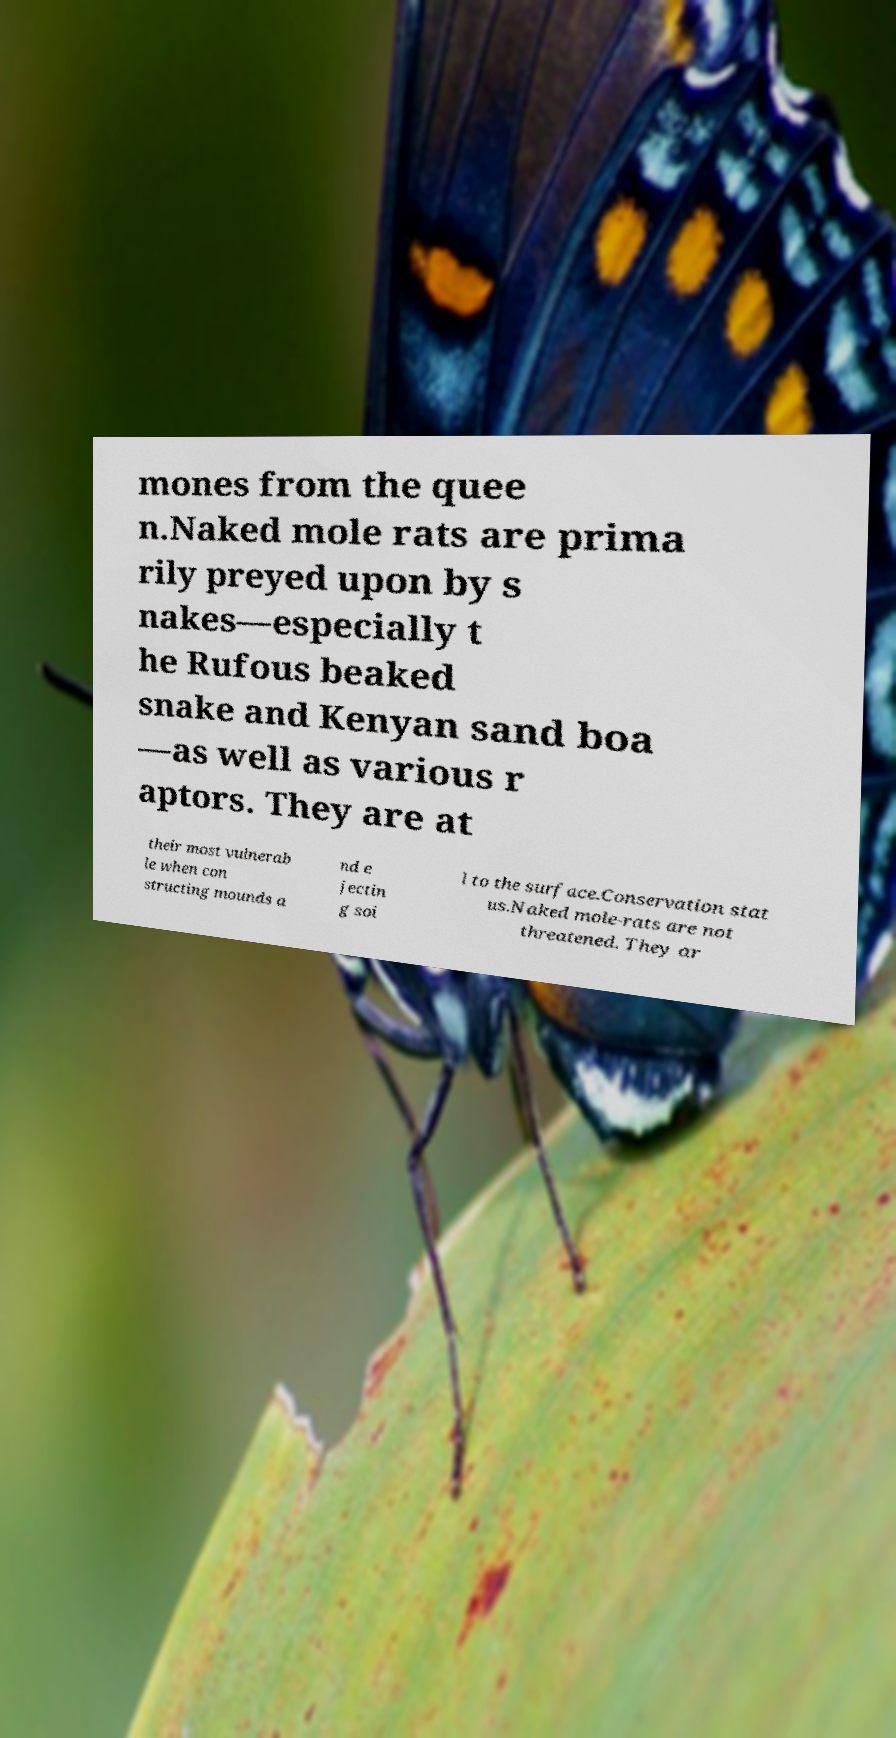For documentation purposes, I need the text within this image transcribed. Could you provide that? mones from the quee n.Naked mole rats are prima rily preyed upon by s nakes—especially t he Rufous beaked snake and Kenyan sand boa —as well as various r aptors. They are at their most vulnerab le when con structing mounds a nd e jectin g soi l to the surface.Conservation stat us.Naked mole-rats are not threatened. They ar 